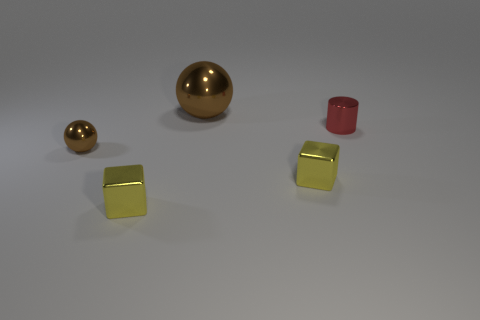The brown thing that is the same size as the cylinder is what shape? The object you're referring to is a sphere. It shares a similar size with the cylinder but differs by having a perfectly rounded surface, lacking any edges or vertices. 